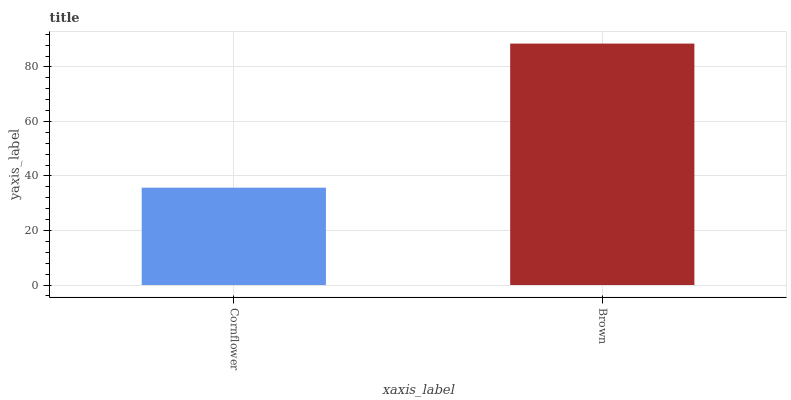Is Cornflower the minimum?
Answer yes or no. Yes. Is Brown the maximum?
Answer yes or no. Yes. Is Brown the minimum?
Answer yes or no. No. Is Brown greater than Cornflower?
Answer yes or no. Yes. Is Cornflower less than Brown?
Answer yes or no. Yes. Is Cornflower greater than Brown?
Answer yes or no. No. Is Brown less than Cornflower?
Answer yes or no. No. Is Brown the high median?
Answer yes or no. Yes. Is Cornflower the low median?
Answer yes or no. Yes. Is Cornflower the high median?
Answer yes or no. No. Is Brown the low median?
Answer yes or no. No. 